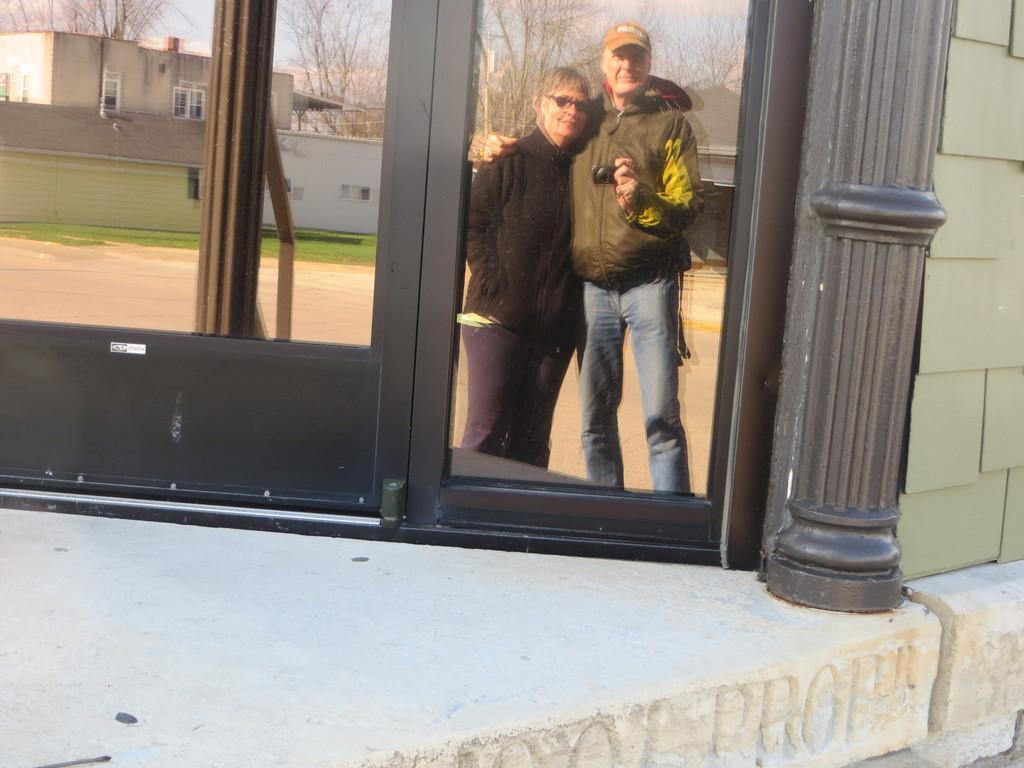Could you give a brief overview of what you see in this image? In this image we can see glass window, house, trees, grass and we can also see two persons standing. 